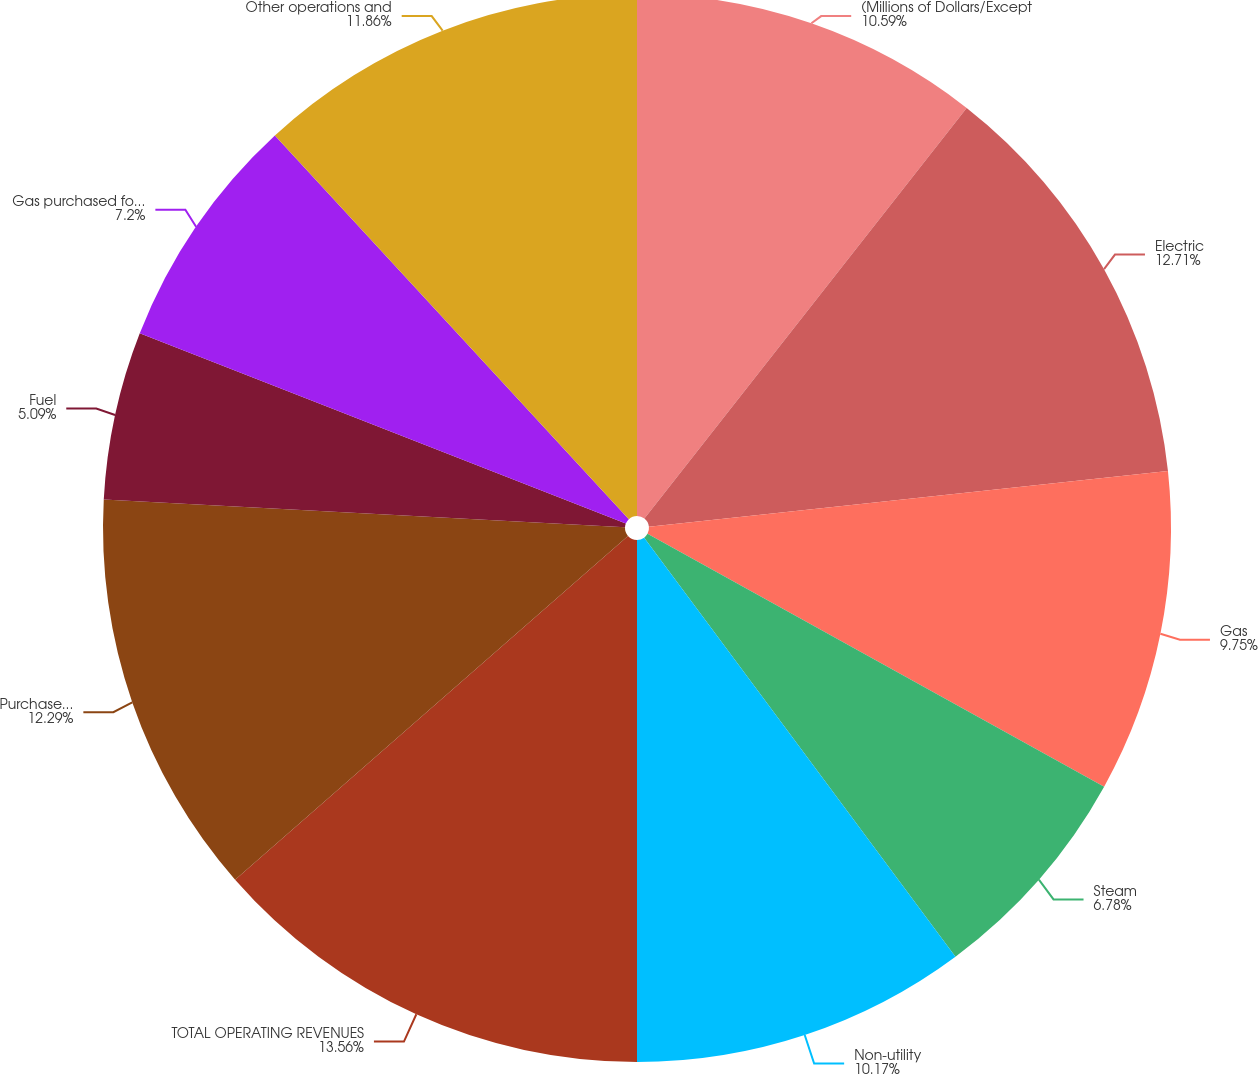Convert chart. <chart><loc_0><loc_0><loc_500><loc_500><pie_chart><fcel>(Millions of Dollars/Except<fcel>Electric<fcel>Gas<fcel>Steam<fcel>Non-utility<fcel>TOTAL OPERATING REVENUES<fcel>Purchased power<fcel>Fuel<fcel>Gas purchased for resale<fcel>Other operations and<nl><fcel>10.59%<fcel>12.71%<fcel>9.75%<fcel>6.78%<fcel>10.17%<fcel>13.56%<fcel>12.29%<fcel>5.09%<fcel>7.2%<fcel>11.86%<nl></chart> 